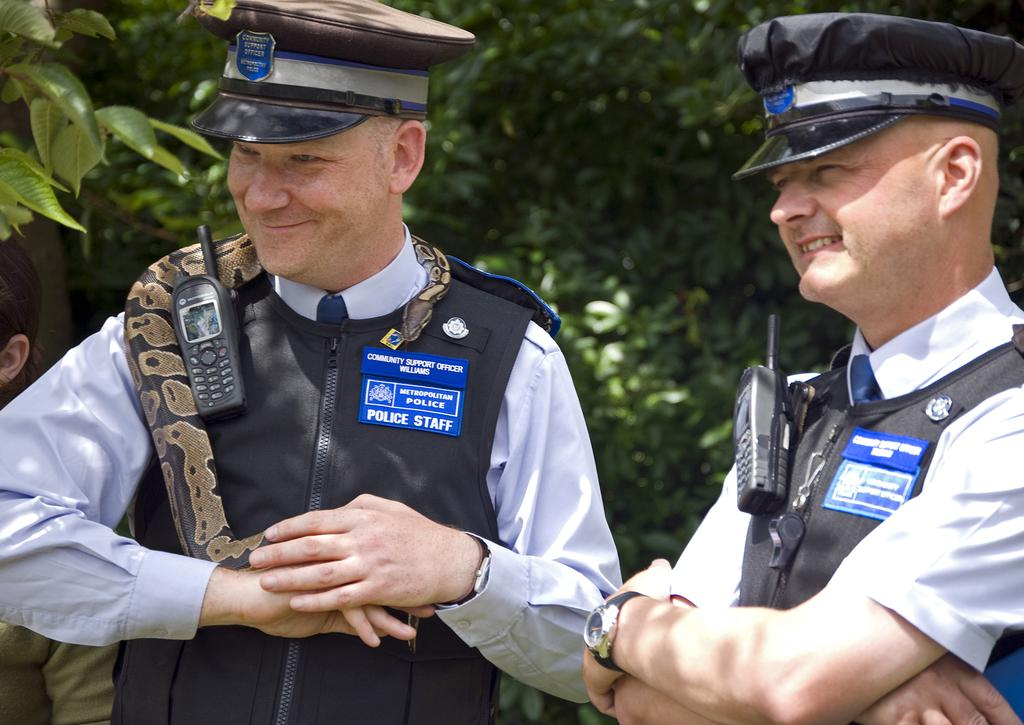<image>
Provide a brief description of the given image. a couple of officers whose shirts say police staff 